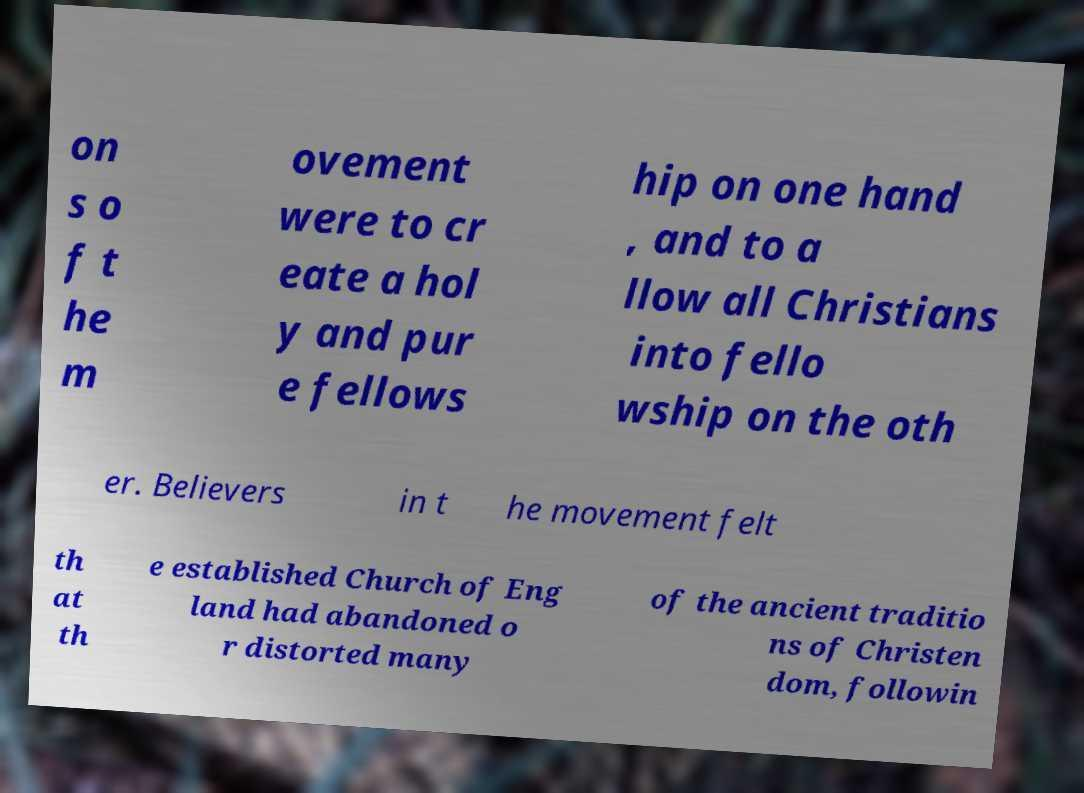Please identify and transcribe the text found in this image. on s o f t he m ovement were to cr eate a hol y and pur e fellows hip on one hand , and to a llow all Christians into fello wship on the oth er. Believers in t he movement felt th at th e established Church of Eng land had abandoned o r distorted many of the ancient traditio ns of Christen dom, followin 